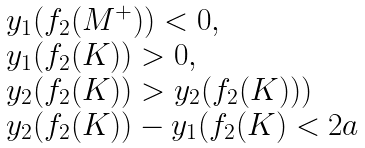<formula> <loc_0><loc_0><loc_500><loc_500>\begin{array} { l } y _ { 1 } ( f _ { 2 } ( M ^ { + } ) ) < 0 , \\ y _ { 1 } ( f _ { 2 } ( K ) ) > 0 , \\ y _ { 2 } ( f _ { 2 } ( K ) ) > y _ { 2 } ( f _ { 2 } ( K ) ) ) \\ y _ { 2 } ( f _ { 2 } ( K ) ) - y _ { 1 } ( f _ { 2 } ( K ) < 2 a \end{array}</formula> 